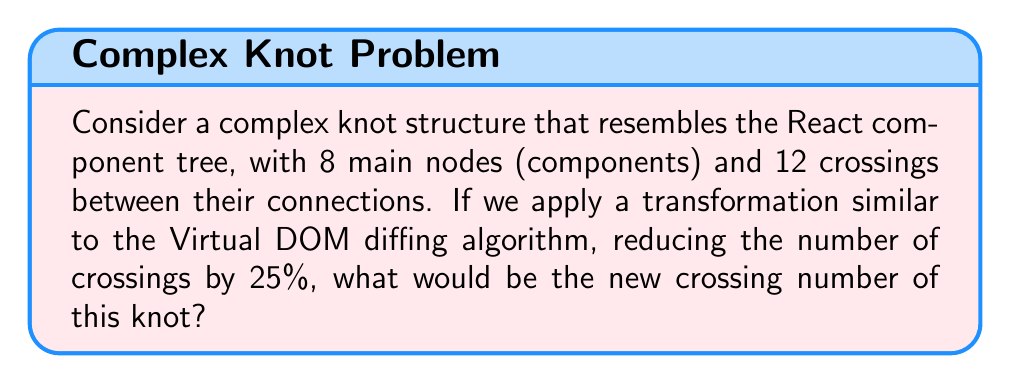Can you solve this math problem? To solve this problem, we'll follow these steps:

1. Identify the initial crossing number:
   The initial crossing number is given as 12.

2. Calculate the reduction percentage:
   The transformation reduces the number of crossings by 25%.

3. Calculate the number of crossings to be removed:
   $$\text{Crossings to remove} = 12 \times 25\% = 12 \times 0.25 = 3$$

4. Calculate the new crossing number:
   $$\text{New crossing number} = \text{Initial crossings} - \text{Crossings removed}$$
   $$\text{New crossing number} = 12 - 3 = 9$$

In knot theory, the crossing number is always a non-negative integer, so our result of 9 is valid.

This transformation can be likened to the way React's Virtual DOM optimizes rendering by minimizing the number of actual DOM manipulations, similar to how Inferno (another UI library) aims to improve performance through efficient DOM updates.
Answer: 9 